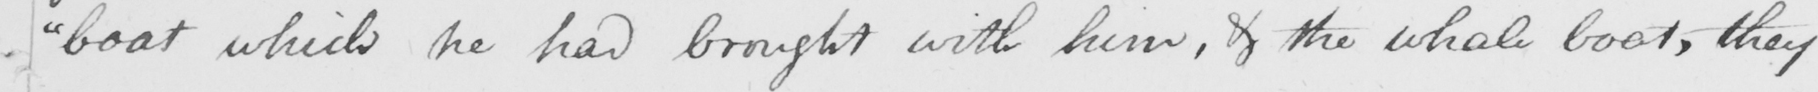What does this handwritten line say? " boat which he had brought with him , & the whale boats , they 